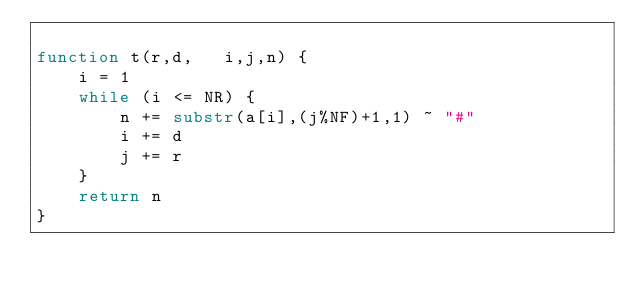Convert code to text. <code><loc_0><loc_0><loc_500><loc_500><_Awk_>
function t(r,d,   i,j,n) {
    i = 1
    while (i <= NR) {
        n += substr(a[i],(j%NF)+1,1) ~ "#"
        i += d
        j += r
    }
    return n
}
</code> 